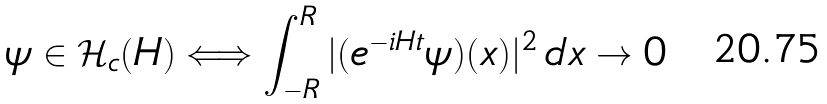Convert formula to latex. <formula><loc_0><loc_0><loc_500><loc_500>\psi \in \mathcal { H } _ { c } ( H ) \Longleftrightarrow \int _ { - R } ^ { R } | ( e ^ { - i H t } \psi ) ( x ) | ^ { 2 } \, d x \rightarrow 0</formula> 